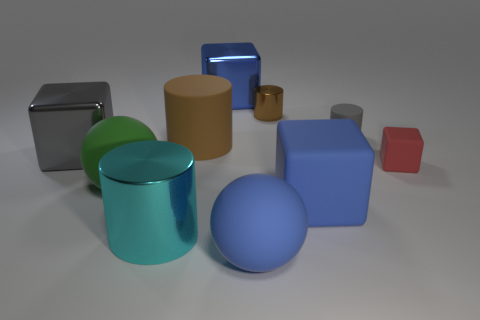Subtract all small red cubes. How many cubes are left? 3 Subtract all blue blocks. How many blocks are left? 2 Subtract 2 cylinders. How many cylinders are left? 2 Add 5 brown metallic objects. How many brown metallic objects are left? 6 Add 8 cyan cylinders. How many cyan cylinders exist? 9 Subtract 1 green balls. How many objects are left? 9 Subtract all balls. How many objects are left? 8 Subtract all cyan spheres. Subtract all brown cylinders. How many spheres are left? 2 Subtract all red cylinders. How many blue cubes are left? 2 Subtract all big rubber blocks. Subtract all big things. How many objects are left? 2 